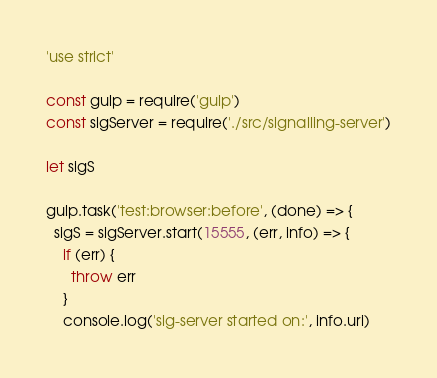<code> <loc_0><loc_0><loc_500><loc_500><_JavaScript_>'use strict'

const gulp = require('gulp')
const sigServer = require('./src/signalling-server')

let sigS

gulp.task('test:browser:before', (done) => {
  sigS = sigServer.start(15555, (err, info) => {
    if (err) {
      throw err
    }
    console.log('sig-server started on:', info.uri)</code> 